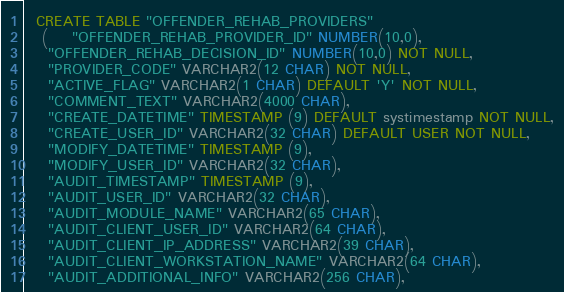<code> <loc_0><loc_0><loc_500><loc_500><_SQL_>
  CREATE TABLE "OFFENDER_REHAB_PROVIDERS"
   (    "OFFENDER_REHAB_PROVIDER_ID" NUMBER(10,0),
    "OFFENDER_REHAB_DECISION_ID" NUMBER(10,0) NOT NULL,
    "PROVIDER_CODE" VARCHAR2(12 CHAR) NOT NULL,
    "ACTIVE_FLAG" VARCHAR2(1 CHAR) DEFAULT 'Y' NOT NULL,
    "COMMENT_TEXT" VARCHAR2(4000 CHAR),
    "CREATE_DATETIME" TIMESTAMP (9) DEFAULT systimestamp NOT NULL,
    "CREATE_USER_ID" VARCHAR2(32 CHAR) DEFAULT USER NOT NULL,
    "MODIFY_DATETIME" TIMESTAMP (9),
    "MODIFY_USER_ID" VARCHAR2(32 CHAR),
    "AUDIT_TIMESTAMP" TIMESTAMP (9),
    "AUDIT_USER_ID" VARCHAR2(32 CHAR),
    "AUDIT_MODULE_NAME" VARCHAR2(65 CHAR),
    "AUDIT_CLIENT_USER_ID" VARCHAR2(64 CHAR),
    "AUDIT_CLIENT_IP_ADDRESS" VARCHAR2(39 CHAR),
    "AUDIT_CLIENT_WORKSTATION_NAME" VARCHAR2(64 CHAR),
    "AUDIT_ADDITIONAL_INFO" VARCHAR2(256 CHAR),</code> 